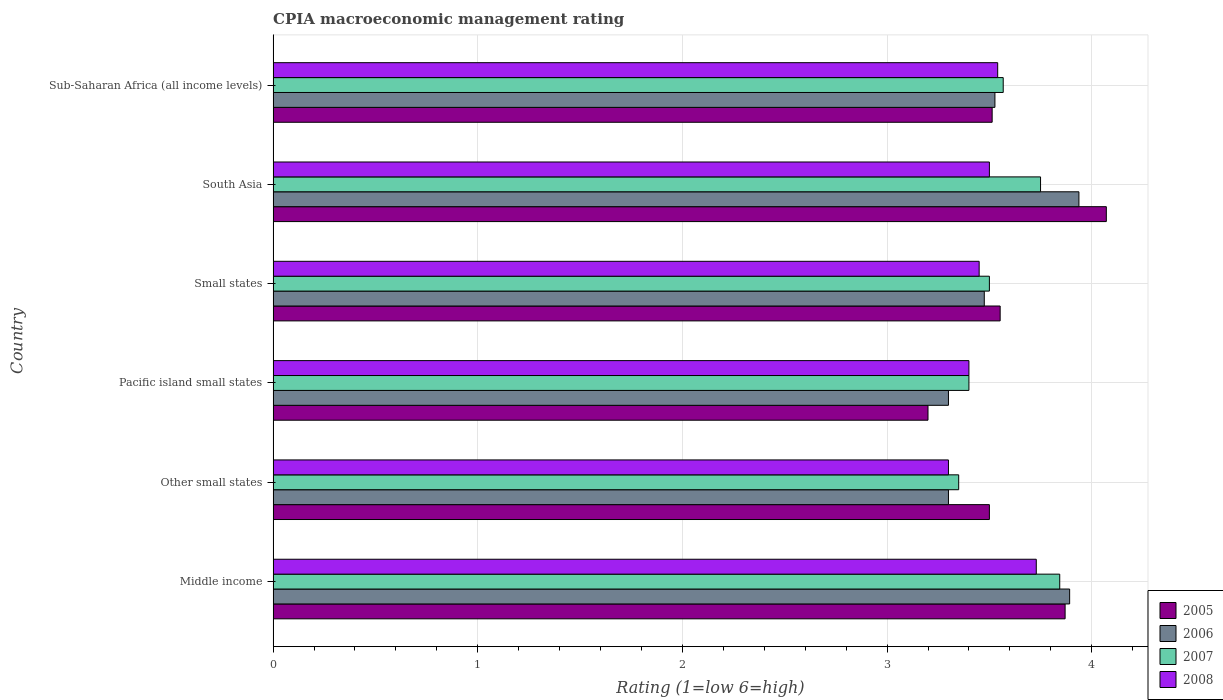How many different coloured bars are there?
Your answer should be very brief. 4. How many groups of bars are there?
Make the answer very short. 6. Are the number of bars on each tick of the Y-axis equal?
Offer a very short reply. Yes. How many bars are there on the 1st tick from the top?
Give a very brief answer. 4. How many bars are there on the 4th tick from the bottom?
Your answer should be compact. 4. What is the label of the 6th group of bars from the top?
Ensure brevity in your answer.  Middle income. What is the CPIA rating in 2005 in Middle income?
Offer a terse response. 3.87. Across all countries, what is the maximum CPIA rating in 2007?
Your answer should be compact. 3.84. Across all countries, what is the minimum CPIA rating in 2007?
Offer a very short reply. 3.35. In which country was the CPIA rating in 2007 maximum?
Offer a terse response. Middle income. In which country was the CPIA rating in 2006 minimum?
Give a very brief answer. Other small states. What is the total CPIA rating in 2007 in the graph?
Ensure brevity in your answer.  21.41. What is the difference between the CPIA rating in 2005 in South Asia and that in Sub-Saharan Africa (all income levels)?
Provide a short and direct response. 0.56. What is the difference between the CPIA rating in 2008 in Sub-Saharan Africa (all income levels) and the CPIA rating in 2006 in Other small states?
Your answer should be very brief. 0.24. What is the average CPIA rating in 2007 per country?
Provide a short and direct response. 3.57. What is the difference between the CPIA rating in 2007 and CPIA rating in 2006 in Sub-Saharan Africa (all income levels)?
Give a very brief answer. 0.04. In how many countries, is the CPIA rating in 2005 greater than 3.4 ?
Provide a short and direct response. 5. What is the ratio of the CPIA rating in 2005 in Middle income to that in Other small states?
Your answer should be compact. 1.11. Is the CPIA rating in 2006 in Middle income less than that in Other small states?
Keep it short and to the point. No. Is the difference between the CPIA rating in 2007 in Other small states and Pacific island small states greater than the difference between the CPIA rating in 2006 in Other small states and Pacific island small states?
Offer a terse response. No. What is the difference between the highest and the second highest CPIA rating in 2006?
Offer a terse response. 0.05. What is the difference between the highest and the lowest CPIA rating in 2008?
Provide a succinct answer. 0.43. In how many countries, is the CPIA rating in 2005 greater than the average CPIA rating in 2005 taken over all countries?
Your response must be concise. 2. Is the sum of the CPIA rating in 2006 in Pacific island small states and Sub-Saharan Africa (all income levels) greater than the maximum CPIA rating in 2008 across all countries?
Offer a terse response. Yes. Is it the case that in every country, the sum of the CPIA rating in 2005 and CPIA rating in 2007 is greater than the sum of CPIA rating in 2008 and CPIA rating in 2006?
Ensure brevity in your answer.  No. How many bars are there?
Your response must be concise. 24. Are all the bars in the graph horizontal?
Your answer should be compact. Yes. How many countries are there in the graph?
Your answer should be very brief. 6. Does the graph contain grids?
Your answer should be very brief. Yes. What is the title of the graph?
Provide a succinct answer. CPIA macroeconomic management rating. What is the label or title of the X-axis?
Give a very brief answer. Rating (1=low 6=high). What is the Rating (1=low 6=high) of 2005 in Middle income?
Provide a short and direct response. 3.87. What is the Rating (1=low 6=high) in 2006 in Middle income?
Offer a very short reply. 3.89. What is the Rating (1=low 6=high) in 2007 in Middle income?
Provide a succinct answer. 3.84. What is the Rating (1=low 6=high) in 2008 in Middle income?
Keep it short and to the point. 3.73. What is the Rating (1=low 6=high) in 2006 in Other small states?
Ensure brevity in your answer.  3.3. What is the Rating (1=low 6=high) of 2007 in Other small states?
Provide a succinct answer. 3.35. What is the Rating (1=low 6=high) of 2006 in Pacific island small states?
Give a very brief answer. 3.3. What is the Rating (1=low 6=high) of 2005 in Small states?
Your answer should be very brief. 3.55. What is the Rating (1=low 6=high) in 2006 in Small states?
Offer a very short reply. 3.48. What is the Rating (1=low 6=high) in 2007 in Small states?
Your answer should be very brief. 3.5. What is the Rating (1=low 6=high) in 2008 in Small states?
Your answer should be compact. 3.45. What is the Rating (1=low 6=high) of 2005 in South Asia?
Ensure brevity in your answer.  4.07. What is the Rating (1=low 6=high) of 2006 in South Asia?
Your answer should be compact. 3.94. What is the Rating (1=low 6=high) in 2007 in South Asia?
Give a very brief answer. 3.75. What is the Rating (1=low 6=high) in 2005 in Sub-Saharan Africa (all income levels)?
Ensure brevity in your answer.  3.51. What is the Rating (1=low 6=high) of 2006 in Sub-Saharan Africa (all income levels)?
Your response must be concise. 3.53. What is the Rating (1=low 6=high) in 2007 in Sub-Saharan Africa (all income levels)?
Your answer should be very brief. 3.57. What is the Rating (1=low 6=high) of 2008 in Sub-Saharan Africa (all income levels)?
Offer a terse response. 3.54. Across all countries, what is the maximum Rating (1=low 6=high) of 2005?
Offer a terse response. 4.07. Across all countries, what is the maximum Rating (1=low 6=high) in 2006?
Offer a very short reply. 3.94. Across all countries, what is the maximum Rating (1=low 6=high) in 2007?
Your response must be concise. 3.84. Across all countries, what is the maximum Rating (1=low 6=high) of 2008?
Offer a very short reply. 3.73. Across all countries, what is the minimum Rating (1=low 6=high) of 2007?
Ensure brevity in your answer.  3.35. What is the total Rating (1=low 6=high) of 2005 in the graph?
Give a very brief answer. 21.71. What is the total Rating (1=low 6=high) of 2006 in the graph?
Ensure brevity in your answer.  21.43. What is the total Rating (1=low 6=high) of 2007 in the graph?
Make the answer very short. 21.41. What is the total Rating (1=low 6=high) of 2008 in the graph?
Provide a short and direct response. 20.92. What is the difference between the Rating (1=low 6=high) of 2005 in Middle income and that in Other small states?
Give a very brief answer. 0.37. What is the difference between the Rating (1=low 6=high) of 2006 in Middle income and that in Other small states?
Keep it short and to the point. 0.59. What is the difference between the Rating (1=low 6=high) of 2007 in Middle income and that in Other small states?
Offer a very short reply. 0.49. What is the difference between the Rating (1=low 6=high) in 2008 in Middle income and that in Other small states?
Give a very brief answer. 0.43. What is the difference between the Rating (1=low 6=high) in 2005 in Middle income and that in Pacific island small states?
Offer a very short reply. 0.67. What is the difference between the Rating (1=low 6=high) in 2006 in Middle income and that in Pacific island small states?
Your response must be concise. 0.59. What is the difference between the Rating (1=low 6=high) of 2007 in Middle income and that in Pacific island small states?
Provide a short and direct response. 0.44. What is the difference between the Rating (1=low 6=high) in 2008 in Middle income and that in Pacific island small states?
Your answer should be very brief. 0.33. What is the difference between the Rating (1=low 6=high) in 2005 in Middle income and that in Small states?
Keep it short and to the point. 0.32. What is the difference between the Rating (1=low 6=high) of 2006 in Middle income and that in Small states?
Ensure brevity in your answer.  0.42. What is the difference between the Rating (1=low 6=high) in 2007 in Middle income and that in Small states?
Give a very brief answer. 0.34. What is the difference between the Rating (1=low 6=high) of 2008 in Middle income and that in Small states?
Make the answer very short. 0.28. What is the difference between the Rating (1=low 6=high) of 2005 in Middle income and that in South Asia?
Give a very brief answer. -0.2. What is the difference between the Rating (1=low 6=high) of 2006 in Middle income and that in South Asia?
Keep it short and to the point. -0.05. What is the difference between the Rating (1=low 6=high) of 2007 in Middle income and that in South Asia?
Your answer should be very brief. 0.09. What is the difference between the Rating (1=low 6=high) in 2008 in Middle income and that in South Asia?
Your answer should be compact. 0.23. What is the difference between the Rating (1=low 6=high) in 2005 in Middle income and that in Sub-Saharan Africa (all income levels)?
Make the answer very short. 0.36. What is the difference between the Rating (1=low 6=high) of 2006 in Middle income and that in Sub-Saharan Africa (all income levels)?
Your answer should be very brief. 0.37. What is the difference between the Rating (1=low 6=high) in 2007 in Middle income and that in Sub-Saharan Africa (all income levels)?
Your response must be concise. 0.28. What is the difference between the Rating (1=low 6=high) in 2008 in Middle income and that in Sub-Saharan Africa (all income levels)?
Provide a short and direct response. 0.19. What is the difference between the Rating (1=low 6=high) in 2008 in Other small states and that in Pacific island small states?
Give a very brief answer. -0.1. What is the difference between the Rating (1=low 6=high) of 2005 in Other small states and that in Small states?
Provide a short and direct response. -0.05. What is the difference between the Rating (1=low 6=high) of 2006 in Other small states and that in Small states?
Your answer should be very brief. -0.17. What is the difference between the Rating (1=low 6=high) in 2007 in Other small states and that in Small states?
Your response must be concise. -0.15. What is the difference between the Rating (1=low 6=high) in 2005 in Other small states and that in South Asia?
Provide a succinct answer. -0.57. What is the difference between the Rating (1=low 6=high) of 2006 in Other small states and that in South Asia?
Give a very brief answer. -0.64. What is the difference between the Rating (1=low 6=high) of 2005 in Other small states and that in Sub-Saharan Africa (all income levels)?
Ensure brevity in your answer.  -0.01. What is the difference between the Rating (1=low 6=high) in 2006 in Other small states and that in Sub-Saharan Africa (all income levels)?
Your answer should be very brief. -0.23. What is the difference between the Rating (1=low 6=high) of 2007 in Other small states and that in Sub-Saharan Africa (all income levels)?
Your answer should be compact. -0.22. What is the difference between the Rating (1=low 6=high) in 2008 in Other small states and that in Sub-Saharan Africa (all income levels)?
Make the answer very short. -0.24. What is the difference between the Rating (1=low 6=high) in 2005 in Pacific island small states and that in Small states?
Your answer should be compact. -0.35. What is the difference between the Rating (1=low 6=high) of 2006 in Pacific island small states and that in Small states?
Your response must be concise. -0.17. What is the difference between the Rating (1=low 6=high) of 2008 in Pacific island small states and that in Small states?
Ensure brevity in your answer.  -0.05. What is the difference between the Rating (1=low 6=high) in 2005 in Pacific island small states and that in South Asia?
Give a very brief answer. -0.87. What is the difference between the Rating (1=low 6=high) of 2006 in Pacific island small states and that in South Asia?
Offer a very short reply. -0.64. What is the difference between the Rating (1=low 6=high) in 2007 in Pacific island small states and that in South Asia?
Make the answer very short. -0.35. What is the difference between the Rating (1=low 6=high) in 2005 in Pacific island small states and that in Sub-Saharan Africa (all income levels)?
Your answer should be very brief. -0.31. What is the difference between the Rating (1=low 6=high) in 2006 in Pacific island small states and that in Sub-Saharan Africa (all income levels)?
Keep it short and to the point. -0.23. What is the difference between the Rating (1=low 6=high) of 2007 in Pacific island small states and that in Sub-Saharan Africa (all income levels)?
Give a very brief answer. -0.17. What is the difference between the Rating (1=low 6=high) in 2008 in Pacific island small states and that in Sub-Saharan Africa (all income levels)?
Provide a succinct answer. -0.14. What is the difference between the Rating (1=low 6=high) of 2005 in Small states and that in South Asia?
Offer a terse response. -0.52. What is the difference between the Rating (1=low 6=high) in 2006 in Small states and that in South Asia?
Keep it short and to the point. -0.46. What is the difference between the Rating (1=low 6=high) of 2007 in Small states and that in South Asia?
Ensure brevity in your answer.  -0.25. What is the difference between the Rating (1=low 6=high) of 2008 in Small states and that in South Asia?
Offer a terse response. -0.05. What is the difference between the Rating (1=low 6=high) in 2005 in Small states and that in Sub-Saharan Africa (all income levels)?
Offer a very short reply. 0.04. What is the difference between the Rating (1=low 6=high) in 2006 in Small states and that in Sub-Saharan Africa (all income levels)?
Ensure brevity in your answer.  -0.05. What is the difference between the Rating (1=low 6=high) of 2007 in Small states and that in Sub-Saharan Africa (all income levels)?
Your response must be concise. -0.07. What is the difference between the Rating (1=low 6=high) in 2008 in Small states and that in Sub-Saharan Africa (all income levels)?
Make the answer very short. -0.09. What is the difference between the Rating (1=low 6=high) in 2005 in South Asia and that in Sub-Saharan Africa (all income levels)?
Your answer should be very brief. 0.56. What is the difference between the Rating (1=low 6=high) in 2006 in South Asia and that in Sub-Saharan Africa (all income levels)?
Provide a short and direct response. 0.41. What is the difference between the Rating (1=low 6=high) in 2007 in South Asia and that in Sub-Saharan Africa (all income levels)?
Provide a short and direct response. 0.18. What is the difference between the Rating (1=low 6=high) of 2008 in South Asia and that in Sub-Saharan Africa (all income levels)?
Offer a very short reply. -0.04. What is the difference between the Rating (1=low 6=high) of 2005 in Middle income and the Rating (1=low 6=high) of 2006 in Other small states?
Ensure brevity in your answer.  0.57. What is the difference between the Rating (1=low 6=high) in 2005 in Middle income and the Rating (1=low 6=high) in 2007 in Other small states?
Provide a short and direct response. 0.52. What is the difference between the Rating (1=low 6=high) in 2005 in Middle income and the Rating (1=low 6=high) in 2008 in Other small states?
Ensure brevity in your answer.  0.57. What is the difference between the Rating (1=low 6=high) of 2006 in Middle income and the Rating (1=low 6=high) of 2007 in Other small states?
Make the answer very short. 0.54. What is the difference between the Rating (1=low 6=high) of 2006 in Middle income and the Rating (1=low 6=high) of 2008 in Other small states?
Provide a short and direct response. 0.59. What is the difference between the Rating (1=low 6=high) of 2007 in Middle income and the Rating (1=low 6=high) of 2008 in Other small states?
Ensure brevity in your answer.  0.54. What is the difference between the Rating (1=low 6=high) in 2005 in Middle income and the Rating (1=low 6=high) in 2006 in Pacific island small states?
Provide a short and direct response. 0.57. What is the difference between the Rating (1=low 6=high) of 2005 in Middle income and the Rating (1=low 6=high) of 2007 in Pacific island small states?
Keep it short and to the point. 0.47. What is the difference between the Rating (1=low 6=high) in 2005 in Middle income and the Rating (1=low 6=high) in 2008 in Pacific island small states?
Your answer should be very brief. 0.47. What is the difference between the Rating (1=low 6=high) of 2006 in Middle income and the Rating (1=low 6=high) of 2007 in Pacific island small states?
Make the answer very short. 0.49. What is the difference between the Rating (1=low 6=high) of 2006 in Middle income and the Rating (1=low 6=high) of 2008 in Pacific island small states?
Offer a terse response. 0.49. What is the difference between the Rating (1=low 6=high) in 2007 in Middle income and the Rating (1=low 6=high) in 2008 in Pacific island small states?
Ensure brevity in your answer.  0.44. What is the difference between the Rating (1=low 6=high) in 2005 in Middle income and the Rating (1=low 6=high) in 2006 in Small states?
Offer a very short reply. 0.4. What is the difference between the Rating (1=low 6=high) of 2005 in Middle income and the Rating (1=low 6=high) of 2007 in Small states?
Your answer should be compact. 0.37. What is the difference between the Rating (1=low 6=high) in 2005 in Middle income and the Rating (1=low 6=high) in 2008 in Small states?
Keep it short and to the point. 0.42. What is the difference between the Rating (1=low 6=high) in 2006 in Middle income and the Rating (1=low 6=high) in 2007 in Small states?
Your response must be concise. 0.39. What is the difference between the Rating (1=low 6=high) in 2006 in Middle income and the Rating (1=low 6=high) in 2008 in Small states?
Your answer should be very brief. 0.44. What is the difference between the Rating (1=low 6=high) in 2007 in Middle income and the Rating (1=low 6=high) in 2008 in Small states?
Give a very brief answer. 0.39. What is the difference between the Rating (1=low 6=high) in 2005 in Middle income and the Rating (1=low 6=high) in 2006 in South Asia?
Your response must be concise. -0.07. What is the difference between the Rating (1=low 6=high) of 2005 in Middle income and the Rating (1=low 6=high) of 2007 in South Asia?
Provide a short and direct response. 0.12. What is the difference between the Rating (1=low 6=high) in 2005 in Middle income and the Rating (1=low 6=high) in 2008 in South Asia?
Keep it short and to the point. 0.37. What is the difference between the Rating (1=low 6=high) of 2006 in Middle income and the Rating (1=low 6=high) of 2007 in South Asia?
Offer a terse response. 0.14. What is the difference between the Rating (1=low 6=high) in 2006 in Middle income and the Rating (1=low 6=high) in 2008 in South Asia?
Keep it short and to the point. 0.39. What is the difference between the Rating (1=low 6=high) of 2007 in Middle income and the Rating (1=low 6=high) of 2008 in South Asia?
Keep it short and to the point. 0.34. What is the difference between the Rating (1=low 6=high) in 2005 in Middle income and the Rating (1=low 6=high) in 2006 in Sub-Saharan Africa (all income levels)?
Provide a short and direct response. 0.34. What is the difference between the Rating (1=low 6=high) in 2005 in Middle income and the Rating (1=low 6=high) in 2007 in Sub-Saharan Africa (all income levels)?
Your response must be concise. 0.3. What is the difference between the Rating (1=low 6=high) in 2005 in Middle income and the Rating (1=low 6=high) in 2008 in Sub-Saharan Africa (all income levels)?
Provide a short and direct response. 0.33. What is the difference between the Rating (1=low 6=high) of 2006 in Middle income and the Rating (1=low 6=high) of 2007 in Sub-Saharan Africa (all income levels)?
Your response must be concise. 0.32. What is the difference between the Rating (1=low 6=high) of 2006 in Middle income and the Rating (1=low 6=high) of 2008 in Sub-Saharan Africa (all income levels)?
Ensure brevity in your answer.  0.35. What is the difference between the Rating (1=low 6=high) in 2007 in Middle income and the Rating (1=low 6=high) in 2008 in Sub-Saharan Africa (all income levels)?
Your answer should be very brief. 0.3. What is the difference between the Rating (1=low 6=high) of 2005 in Other small states and the Rating (1=low 6=high) of 2006 in Pacific island small states?
Make the answer very short. 0.2. What is the difference between the Rating (1=low 6=high) in 2005 in Other small states and the Rating (1=low 6=high) in 2007 in Pacific island small states?
Offer a very short reply. 0.1. What is the difference between the Rating (1=low 6=high) of 2005 in Other small states and the Rating (1=low 6=high) of 2008 in Pacific island small states?
Ensure brevity in your answer.  0.1. What is the difference between the Rating (1=low 6=high) in 2006 in Other small states and the Rating (1=low 6=high) in 2007 in Pacific island small states?
Your answer should be compact. -0.1. What is the difference between the Rating (1=low 6=high) of 2005 in Other small states and the Rating (1=low 6=high) of 2006 in Small states?
Your answer should be compact. 0.03. What is the difference between the Rating (1=low 6=high) of 2005 in Other small states and the Rating (1=low 6=high) of 2007 in Small states?
Your response must be concise. 0. What is the difference between the Rating (1=low 6=high) in 2005 in Other small states and the Rating (1=low 6=high) in 2008 in Small states?
Ensure brevity in your answer.  0.05. What is the difference between the Rating (1=low 6=high) of 2007 in Other small states and the Rating (1=low 6=high) of 2008 in Small states?
Offer a terse response. -0.1. What is the difference between the Rating (1=low 6=high) in 2005 in Other small states and the Rating (1=low 6=high) in 2006 in South Asia?
Keep it short and to the point. -0.44. What is the difference between the Rating (1=low 6=high) of 2005 in Other small states and the Rating (1=low 6=high) of 2007 in South Asia?
Provide a short and direct response. -0.25. What is the difference between the Rating (1=low 6=high) in 2006 in Other small states and the Rating (1=low 6=high) in 2007 in South Asia?
Your answer should be very brief. -0.45. What is the difference between the Rating (1=low 6=high) of 2006 in Other small states and the Rating (1=low 6=high) of 2008 in South Asia?
Provide a succinct answer. -0.2. What is the difference between the Rating (1=low 6=high) in 2007 in Other small states and the Rating (1=low 6=high) in 2008 in South Asia?
Offer a very short reply. -0.15. What is the difference between the Rating (1=low 6=high) in 2005 in Other small states and the Rating (1=low 6=high) in 2006 in Sub-Saharan Africa (all income levels)?
Offer a very short reply. -0.03. What is the difference between the Rating (1=low 6=high) of 2005 in Other small states and the Rating (1=low 6=high) of 2007 in Sub-Saharan Africa (all income levels)?
Offer a terse response. -0.07. What is the difference between the Rating (1=low 6=high) in 2005 in Other small states and the Rating (1=low 6=high) in 2008 in Sub-Saharan Africa (all income levels)?
Provide a short and direct response. -0.04. What is the difference between the Rating (1=low 6=high) of 2006 in Other small states and the Rating (1=low 6=high) of 2007 in Sub-Saharan Africa (all income levels)?
Offer a very short reply. -0.27. What is the difference between the Rating (1=low 6=high) in 2006 in Other small states and the Rating (1=low 6=high) in 2008 in Sub-Saharan Africa (all income levels)?
Your answer should be very brief. -0.24. What is the difference between the Rating (1=low 6=high) in 2007 in Other small states and the Rating (1=low 6=high) in 2008 in Sub-Saharan Africa (all income levels)?
Your response must be concise. -0.19. What is the difference between the Rating (1=low 6=high) of 2005 in Pacific island small states and the Rating (1=low 6=high) of 2006 in Small states?
Make the answer very short. -0.28. What is the difference between the Rating (1=low 6=high) of 2006 in Pacific island small states and the Rating (1=low 6=high) of 2008 in Small states?
Make the answer very short. -0.15. What is the difference between the Rating (1=low 6=high) of 2007 in Pacific island small states and the Rating (1=low 6=high) of 2008 in Small states?
Your answer should be very brief. -0.05. What is the difference between the Rating (1=low 6=high) of 2005 in Pacific island small states and the Rating (1=low 6=high) of 2006 in South Asia?
Offer a terse response. -0.74. What is the difference between the Rating (1=low 6=high) of 2005 in Pacific island small states and the Rating (1=low 6=high) of 2007 in South Asia?
Offer a terse response. -0.55. What is the difference between the Rating (1=low 6=high) of 2005 in Pacific island small states and the Rating (1=low 6=high) of 2008 in South Asia?
Offer a terse response. -0.3. What is the difference between the Rating (1=low 6=high) in 2006 in Pacific island small states and the Rating (1=low 6=high) in 2007 in South Asia?
Offer a very short reply. -0.45. What is the difference between the Rating (1=low 6=high) in 2006 in Pacific island small states and the Rating (1=low 6=high) in 2008 in South Asia?
Provide a short and direct response. -0.2. What is the difference between the Rating (1=low 6=high) in 2007 in Pacific island small states and the Rating (1=low 6=high) in 2008 in South Asia?
Make the answer very short. -0.1. What is the difference between the Rating (1=low 6=high) in 2005 in Pacific island small states and the Rating (1=low 6=high) in 2006 in Sub-Saharan Africa (all income levels)?
Give a very brief answer. -0.33. What is the difference between the Rating (1=low 6=high) in 2005 in Pacific island small states and the Rating (1=low 6=high) in 2007 in Sub-Saharan Africa (all income levels)?
Your answer should be compact. -0.37. What is the difference between the Rating (1=low 6=high) in 2005 in Pacific island small states and the Rating (1=low 6=high) in 2008 in Sub-Saharan Africa (all income levels)?
Give a very brief answer. -0.34. What is the difference between the Rating (1=low 6=high) of 2006 in Pacific island small states and the Rating (1=low 6=high) of 2007 in Sub-Saharan Africa (all income levels)?
Your response must be concise. -0.27. What is the difference between the Rating (1=low 6=high) in 2006 in Pacific island small states and the Rating (1=low 6=high) in 2008 in Sub-Saharan Africa (all income levels)?
Provide a short and direct response. -0.24. What is the difference between the Rating (1=low 6=high) of 2007 in Pacific island small states and the Rating (1=low 6=high) of 2008 in Sub-Saharan Africa (all income levels)?
Offer a very short reply. -0.14. What is the difference between the Rating (1=low 6=high) in 2005 in Small states and the Rating (1=low 6=high) in 2006 in South Asia?
Offer a terse response. -0.38. What is the difference between the Rating (1=low 6=high) of 2005 in Small states and the Rating (1=low 6=high) of 2007 in South Asia?
Provide a succinct answer. -0.2. What is the difference between the Rating (1=low 6=high) in 2005 in Small states and the Rating (1=low 6=high) in 2008 in South Asia?
Offer a very short reply. 0.05. What is the difference between the Rating (1=low 6=high) of 2006 in Small states and the Rating (1=low 6=high) of 2007 in South Asia?
Offer a very short reply. -0.28. What is the difference between the Rating (1=low 6=high) in 2006 in Small states and the Rating (1=low 6=high) in 2008 in South Asia?
Keep it short and to the point. -0.03. What is the difference between the Rating (1=low 6=high) of 2007 in Small states and the Rating (1=low 6=high) of 2008 in South Asia?
Provide a succinct answer. 0. What is the difference between the Rating (1=low 6=high) of 2005 in Small states and the Rating (1=low 6=high) of 2006 in Sub-Saharan Africa (all income levels)?
Your answer should be compact. 0.03. What is the difference between the Rating (1=low 6=high) of 2005 in Small states and the Rating (1=low 6=high) of 2007 in Sub-Saharan Africa (all income levels)?
Provide a succinct answer. -0.01. What is the difference between the Rating (1=low 6=high) in 2005 in Small states and the Rating (1=low 6=high) in 2008 in Sub-Saharan Africa (all income levels)?
Provide a short and direct response. 0.01. What is the difference between the Rating (1=low 6=high) in 2006 in Small states and the Rating (1=low 6=high) in 2007 in Sub-Saharan Africa (all income levels)?
Ensure brevity in your answer.  -0.09. What is the difference between the Rating (1=low 6=high) in 2006 in Small states and the Rating (1=low 6=high) in 2008 in Sub-Saharan Africa (all income levels)?
Ensure brevity in your answer.  -0.07. What is the difference between the Rating (1=low 6=high) of 2007 in Small states and the Rating (1=low 6=high) of 2008 in Sub-Saharan Africa (all income levels)?
Offer a terse response. -0.04. What is the difference between the Rating (1=low 6=high) in 2005 in South Asia and the Rating (1=low 6=high) in 2006 in Sub-Saharan Africa (all income levels)?
Your response must be concise. 0.54. What is the difference between the Rating (1=low 6=high) in 2005 in South Asia and the Rating (1=low 6=high) in 2007 in Sub-Saharan Africa (all income levels)?
Keep it short and to the point. 0.5. What is the difference between the Rating (1=low 6=high) of 2005 in South Asia and the Rating (1=low 6=high) of 2008 in Sub-Saharan Africa (all income levels)?
Your answer should be compact. 0.53. What is the difference between the Rating (1=low 6=high) in 2006 in South Asia and the Rating (1=low 6=high) in 2007 in Sub-Saharan Africa (all income levels)?
Provide a short and direct response. 0.37. What is the difference between the Rating (1=low 6=high) in 2006 in South Asia and the Rating (1=low 6=high) in 2008 in Sub-Saharan Africa (all income levels)?
Your answer should be compact. 0.4. What is the difference between the Rating (1=low 6=high) of 2007 in South Asia and the Rating (1=low 6=high) of 2008 in Sub-Saharan Africa (all income levels)?
Offer a very short reply. 0.21. What is the average Rating (1=low 6=high) of 2005 per country?
Offer a very short reply. 3.62. What is the average Rating (1=low 6=high) in 2006 per country?
Keep it short and to the point. 3.57. What is the average Rating (1=low 6=high) of 2007 per country?
Your response must be concise. 3.57. What is the average Rating (1=low 6=high) in 2008 per country?
Offer a very short reply. 3.49. What is the difference between the Rating (1=low 6=high) in 2005 and Rating (1=low 6=high) in 2006 in Middle income?
Ensure brevity in your answer.  -0.02. What is the difference between the Rating (1=low 6=high) in 2005 and Rating (1=low 6=high) in 2007 in Middle income?
Make the answer very short. 0.03. What is the difference between the Rating (1=low 6=high) of 2005 and Rating (1=low 6=high) of 2008 in Middle income?
Provide a succinct answer. 0.14. What is the difference between the Rating (1=low 6=high) of 2006 and Rating (1=low 6=high) of 2007 in Middle income?
Provide a short and direct response. 0.05. What is the difference between the Rating (1=low 6=high) of 2006 and Rating (1=low 6=high) of 2008 in Middle income?
Offer a terse response. 0.16. What is the difference between the Rating (1=low 6=high) in 2007 and Rating (1=low 6=high) in 2008 in Middle income?
Your answer should be compact. 0.11. What is the difference between the Rating (1=low 6=high) of 2005 and Rating (1=low 6=high) of 2008 in Other small states?
Offer a very short reply. 0.2. What is the difference between the Rating (1=low 6=high) of 2006 and Rating (1=low 6=high) of 2007 in Other small states?
Ensure brevity in your answer.  -0.05. What is the difference between the Rating (1=low 6=high) of 2006 and Rating (1=low 6=high) of 2008 in Pacific island small states?
Offer a very short reply. -0.1. What is the difference between the Rating (1=low 6=high) in 2007 and Rating (1=low 6=high) in 2008 in Pacific island small states?
Offer a very short reply. 0. What is the difference between the Rating (1=low 6=high) in 2005 and Rating (1=low 6=high) in 2006 in Small states?
Make the answer very short. 0.08. What is the difference between the Rating (1=low 6=high) in 2005 and Rating (1=low 6=high) in 2007 in Small states?
Provide a succinct answer. 0.05. What is the difference between the Rating (1=low 6=high) in 2005 and Rating (1=low 6=high) in 2008 in Small states?
Give a very brief answer. 0.1. What is the difference between the Rating (1=low 6=high) in 2006 and Rating (1=low 6=high) in 2007 in Small states?
Keep it short and to the point. -0.03. What is the difference between the Rating (1=low 6=high) in 2006 and Rating (1=low 6=high) in 2008 in Small states?
Make the answer very short. 0.03. What is the difference between the Rating (1=low 6=high) of 2007 and Rating (1=low 6=high) of 2008 in Small states?
Make the answer very short. 0.05. What is the difference between the Rating (1=low 6=high) of 2005 and Rating (1=low 6=high) of 2006 in South Asia?
Give a very brief answer. 0.13. What is the difference between the Rating (1=low 6=high) of 2005 and Rating (1=low 6=high) of 2007 in South Asia?
Your answer should be compact. 0.32. What is the difference between the Rating (1=low 6=high) in 2006 and Rating (1=low 6=high) in 2007 in South Asia?
Your answer should be compact. 0.19. What is the difference between the Rating (1=low 6=high) in 2006 and Rating (1=low 6=high) in 2008 in South Asia?
Keep it short and to the point. 0.44. What is the difference between the Rating (1=low 6=high) in 2007 and Rating (1=low 6=high) in 2008 in South Asia?
Your response must be concise. 0.25. What is the difference between the Rating (1=low 6=high) in 2005 and Rating (1=low 6=high) in 2006 in Sub-Saharan Africa (all income levels)?
Make the answer very short. -0.01. What is the difference between the Rating (1=low 6=high) of 2005 and Rating (1=low 6=high) of 2007 in Sub-Saharan Africa (all income levels)?
Make the answer very short. -0.05. What is the difference between the Rating (1=low 6=high) of 2005 and Rating (1=low 6=high) of 2008 in Sub-Saharan Africa (all income levels)?
Your answer should be compact. -0.03. What is the difference between the Rating (1=low 6=high) in 2006 and Rating (1=low 6=high) in 2007 in Sub-Saharan Africa (all income levels)?
Provide a succinct answer. -0.04. What is the difference between the Rating (1=low 6=high) of 2006 and Rating (1=low 6=high) of 2008 in Sub-Saharan Africa (all income levels)?
Keep it short and to the point. -0.01. What is the difference between the Rating (1=low 6=high) in 2007 and Rating (1=low 6=high) in 2008 in Sub-Saharan Africa (all income levels)?
Ensure brevity in your answer.  0.03. What is the ratio of the Rating (1=low 6=high) of 2005 in Middle income to that in Other small states?
Your response must be concise. 1.11. What is the ratio of the Rating (1=low 6=high) in 2006 in Middle income to that in Other small states?
Your response must be concise. 1.18. What is the ratio of the Rating (1=low 6=high) in 2007 in Middle income to that in Other small states?
Give a very brief answer. 1.15. What is the ratio of the Rating (1=low 6=high) in 2008 in Middle income to that in Other small states?
Offer a very short reply. 1.13. What is the ratio of the Rating (1=low 6=high) in 2005 in Middle income to that in Pacific island small states?
Offer a terse response. 1.21. What is the ratio of the Rating (1=low 6=high) of 2006 in Middle income to that in Pacific island small states?
Keep it short and to the point. 1.18. What is the ratio of the Rating (1=low 6=high) in 2007 in Middle income to that in Pacific island small states?
Offer a terse response. 1.13. What is the ratio of the Rating (1=low 6=high) of 2008 in Middle income to that in Pacific island small states?
Provide a short and direct response. 1.1. What is the ratio of the Rating (1=low 6=high) of 2005 in Middle income to that in Small states?
Provide a short and direct response. 1.09. What is the ratio of the Rating (1=low 6=high) of 2006 in Middle income to that in Small states?
Keep it short and to the point. 1.12. What is the ratio of the Rating (1=low 6=high) of 2007 in Middle income to that in Small states?
Provide a short and direct response. 1.1. What is the ratio of the Rating (1=low 6=high) in 2008 in Middle income to that in Small states?
Give a very brief answer. 1.08. What is the ratio of the Rating (1=low 6=high) of 2005 in Middle income to that in South Asia?
Ensure brevity in your answer.  0.95. What is the ratio of the Rating (1=low 6=high) in 2006 in Middle income to that in South Asia?
Your response must be concise. 0.99. What is the ratio of the Rating (1=low 6=high) in 2008 in Middle income to that in South Asia?
Provide a succinct answer. 1.07. What is the ratio of the Rating (1=low 6=high) of 2005 in Middle income to that in Sub-Saharan Africa (all income levels)?
Make the answer very short. 1.1. What is the ratio of the Rating (1=low 6=high) of 2006 in Middle income to that in Sub-Saharan Africa (all income levels)?
Provide a succinct answer. 1.1. What is the ratio of the Rating (1=low 6=high) in 2007 in Middle income to that in Sub-Saharan Africa (all income levels)?
Provide a short and direct response. 1.08. What is the ratio of the Rating (1=low 6=high) of 2008 in Middle income to that in Sub-Saharan Africa (all income levels)?
Provide a short and direct response. 1.05. What is the ratio of the Rating (1=low 6=high) in 2005 in Other small states to that in Pacific island small states?
Your response must be concise. 1.09. What is the ratio of the Rating (1=low 6=high) of 2006 in Other small states to that in Pacific island small states?
Provide a short and direct response. 1. What is the ratio of the Rating (1=low 6=high) in 2008 in Other small states to that in Pacific island small states?
Provide a succinct answer. 0.97. What is the ratio of the Rating (1=low 6=high) in 2005 in Other small states to that in Small states?
Your answer should be very brief. 0.99. What is the ratio of the Rating (1=low 6=high) in 2006 in Other small states to that in Small states?
Ensure brevity in your answer.  0.95. What is the ratio of the Rating (1=low 6=high) of 2007 in Other small states to that in Small states?
Ensure brevity in your answer.  0.96. What is the ratio of the Rating (1=low 6=high) of 2008 in Other small states to that in Small states?
Your answer should be very brief. 0.96. What is the ratio of the Rating (1=low 6=high) in 2005 in Other small states to that in South Asia?
Your answer should be compact. 0.86. What is the ratio of the Rating (1=low 6=high) of 2006 in Other small states to that in South Asia?
Make the answer very short. 0.84. What is the ratio of the Rating (1=low 6=high) of 2007 in Other small states to that in South Asia?
Your answer should be very brief. 0.89. What is the ratio of the Rating (1=low 6=high) of 2008 in Other small states to that in South Asia?
Provide a succinct answer. 0.94. What is the ratio of the Rating (1=low 6=high) in 2005 in Other small states to that in Sub-Saharan Africa (all income levels)?
Offer a terse response. 1. What is the ratio of the Rating (1=low 6=high) in 2006 in Other small states to that in Sub-Saharan Africa (all income levels)?
Your answer should be compact. 0.94. What is the ratio of the Rating (1=low 6=high) in 2007 in Other small states to that in Sub-Saharan Africa (all income levels)?
Make the answer very short. 0.94. What is the ratio of the Rating (1=low 6=high) of 2008 in Other small states to that in Sub-Saharan Africa (all income levels)?
Ensure brevity in your answer.  0.93. What is the ratio of the Rating (1=low 6=high) in 2005 in Pacific island small states to that in Small states?
Make the answer very short. 0.9. What is the ratio of the Rating (1=low 6=high) in 2006 in Pacific island small states to that in Small states?
Your answer should be compact. 0.95. What is the ratio of the Rating (1=low 6=high) of 2007 in Pacific island small states to that in Small states?
Offer a terse response. 0.97. What is the ratio of the Rating (1=low 6=high) in 2008 in Pacific island small states to that in Small states?
Your answer should be very brief. 0.99. What is the ratio of the Rating (1=low 6=high) of 2005 in Pacific island small states to that in South Asia?
Offer a very short reply. 0.79. What is the ratio of the Rating (1=low 6=high) in 2006 in Pacific island small states to that in South Asia?
Offer a very short reply. 0.84. What is the ratio of the Rating (1=low 6=high) in 2007 in Pacific island small states to that in South Asia?
Keep it short and to the point. 0.91. What is the ratio of the Rating (1=low 6=high) in 2008 in Pacific island small states to that in South Asia?
Give a very brief answer. 0.97. What is the ratio of the Rating (1=low 6=high) of 2005 in Pacific island small states to that in Sub-Saharan Africa (all income levels)?
Make the answer very short. 0.91. What is the ratio of the Rating (1=low 6=high) in 2006 in Pacific island small states to that in Sub-Saharan Africa (all income levels)?
Ensure brevity in your answer.  0.94. What is the ratio of the Rating (1=low 6=high) in 2007 in Pacific island small states to that in Sub-Saharan Africa (all income levels)?
Make the answer very short. 0.95. What is the ratio of the Rating (1=low 6=high) of 2008 in Pacific island small states to that in Sub-Saharan Africa (all income levels)?
Provide a short and direct response. 0.96. What is the ratio of the Rating (1=low 6=high) in 2005 in Small states to that in South Asia?
Provide a succinct answer. 0.87. What is the ratio of the Rating (1=low 6=high) of 2006 in Small states to that in South Asia?
Your answer should be compact. 0.88. What is the ratio of the Rating (1=low 6=high) in 2008 in Small states to that in South Asia?
Provide a succinct answer. 0.99. What is the ratio of the Rating (1=low 6=high) of 2005 in Small states to that in Sub-Saharan Africa (all income levels)?
Provide a succinct answer. 1.01. What is the ratio of the Rating (1=low 6=high) in 2006 in Small states to that in Sub-Saharan Africa (all income levels)?
Keep it short and to the point. 0.99. What is the ratio of the Rating (1=low 6=high) in 2007 in Small states to that in Sub-Saharan Africa (all income levels)?
Provide a short and direct response. 0.98. What is the ratio of the Rating (1=low 6=high) in 2008 in Small states to that in Sub-Saharan Africa (all income levels)?
Give a very brief answer. 0.97. What is the ratio of the Rating (1=low 6=high) in 2005 in South Asia to that in Sub-Saharan Africa (all income levels)?
Offer a very short reply. 1.16. What is the ratio of the Rating (1=low 6=high) in 2006 in South Asia to that in Sub-Saharan Africa (all income levels)?
Give a very brief answer. 1.12. What is the ratio of the Rating (1=low 6=high) of 2007 in South Asia to that in Sub-Saharan Africa (all income levels)?
Keep it short and to the point. 1.05. What is the ratio of the Rating (1=low 6=high) of 2008 in South Asia to that in Sub-Saharan Africa (all income levels)?
Give a very brief answer. 0.99. What is the difference between the highest and the second highest Rating (1=low 6=high) in 2005?
Your answer should be very brief. 0.2. What is the difference between the highest and the second highest Rating (1=low 6=high) in 2006?
Offer a very short reply. 0.05. What is the difference between the highest and the second highest Rating (1=low 6=high) in 2007?
Your answer should be compact. 0.09. What is the difference between the highest and the second highest Rating (1=low 6=high) of 2008?
Your answer should be compact. 0.19. What is the difference between the highest and the lowest Rating (1=low 6=high) in 2005?
Offer a very short reply. 0.87. What is the difference between the highest and the lowest Rating (1=low 6=high) in 2006?
Ensure brevity in your answer.  0.64. What is the difference between the highest and the lowest Rating (1=low 6=high) in 2007?
Offer a terse response. 0.49. What is the difference between the highest and the lowest Rating (1=low 6=high) in 2008?
Provide a succinct answer. 0.43. 